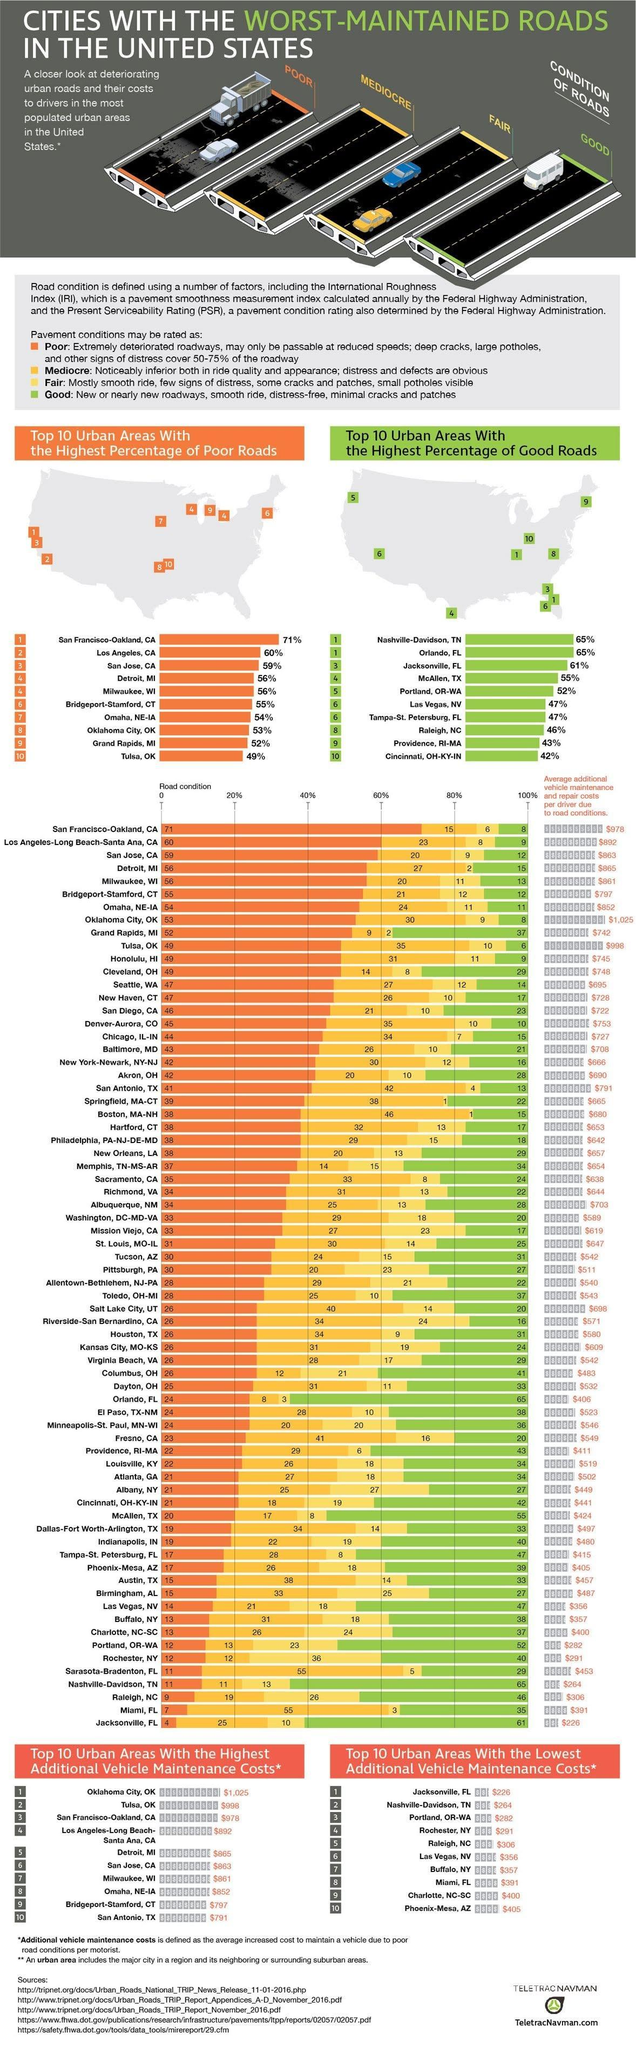Which urban area in U.S. has the second lowest additional vehicle maintenance costs?
Answer the question with a short phrase. Nashville-Davidson, TN What percent of roads are in poor condition in San Jose, CA? 59% What percent of roads are in good condition in urban areas of Raleigh, NC? 46% What is the additional vehicle maintenance cost in urban areas of Rochester, NY? $291 What percent of roads are in good condition in McAllen, TX? 55% Which urban area in U.S. has the second highest additional vehicle maintenance costs? Tulsa, OK Which is the top no.1 city in U.S. with the lowest additional vehicle maintenance costs? Jacksonville, FL Which is the top no.1 city in U.S. with the highest additional vehicle maintenance costs? Oklahoma City, OK 